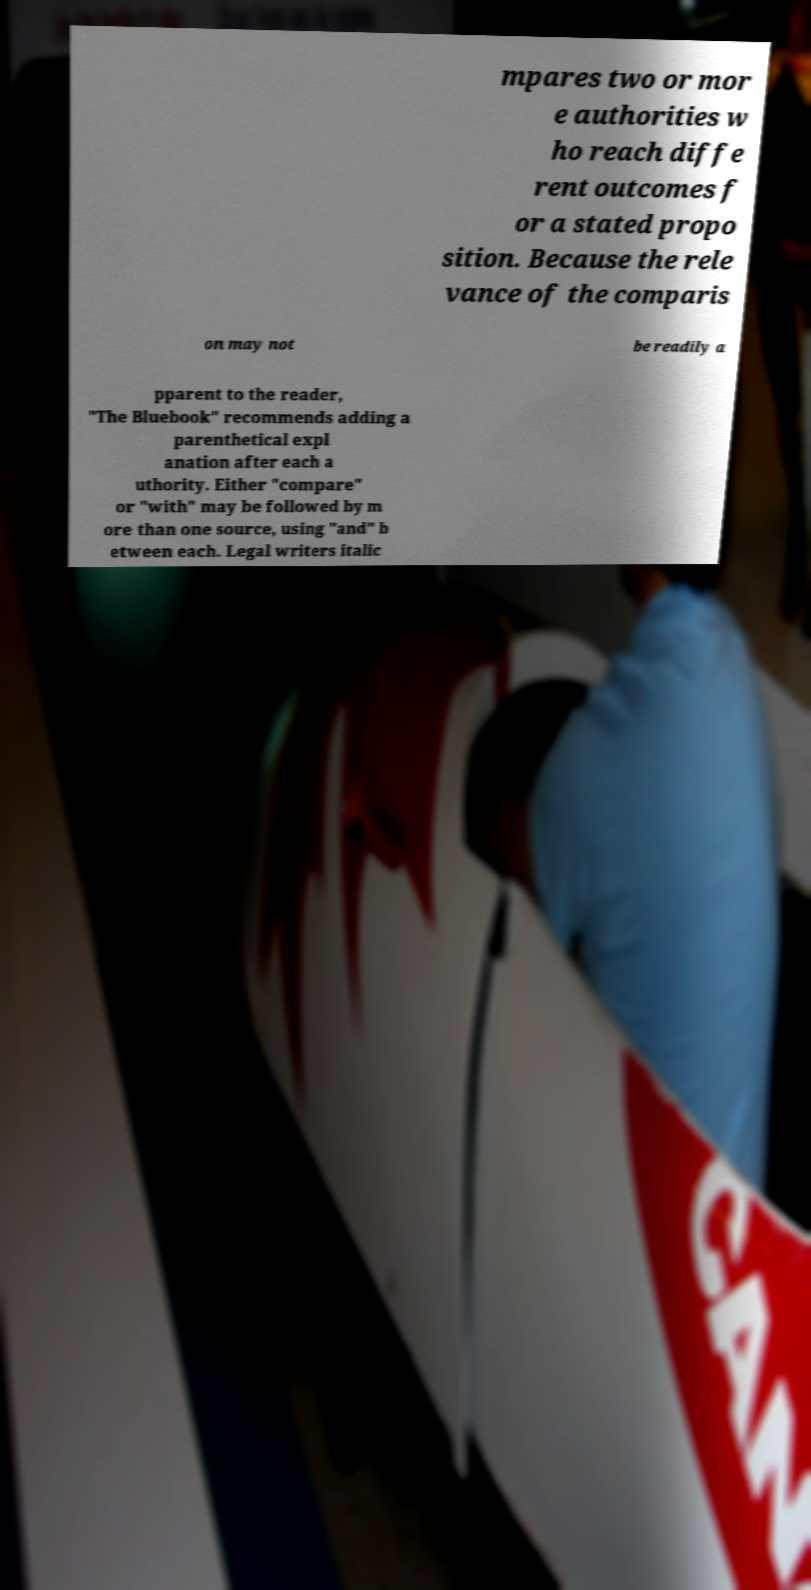For documentation purposes, I need the text within this image transcribed. Could you provide that? mpares two or mor e authorities w ho reach diffe rent outcomes f or a stated propo sition. Because the rele vance of the comparis on may not be readily a pparent to the reader, "The Bluebook" recommends adding a parenthetical expl anation after each a uthority. Either "compare" or "with" may be followed by m ore than one source, using "and" b etween each. Legal writers italic 